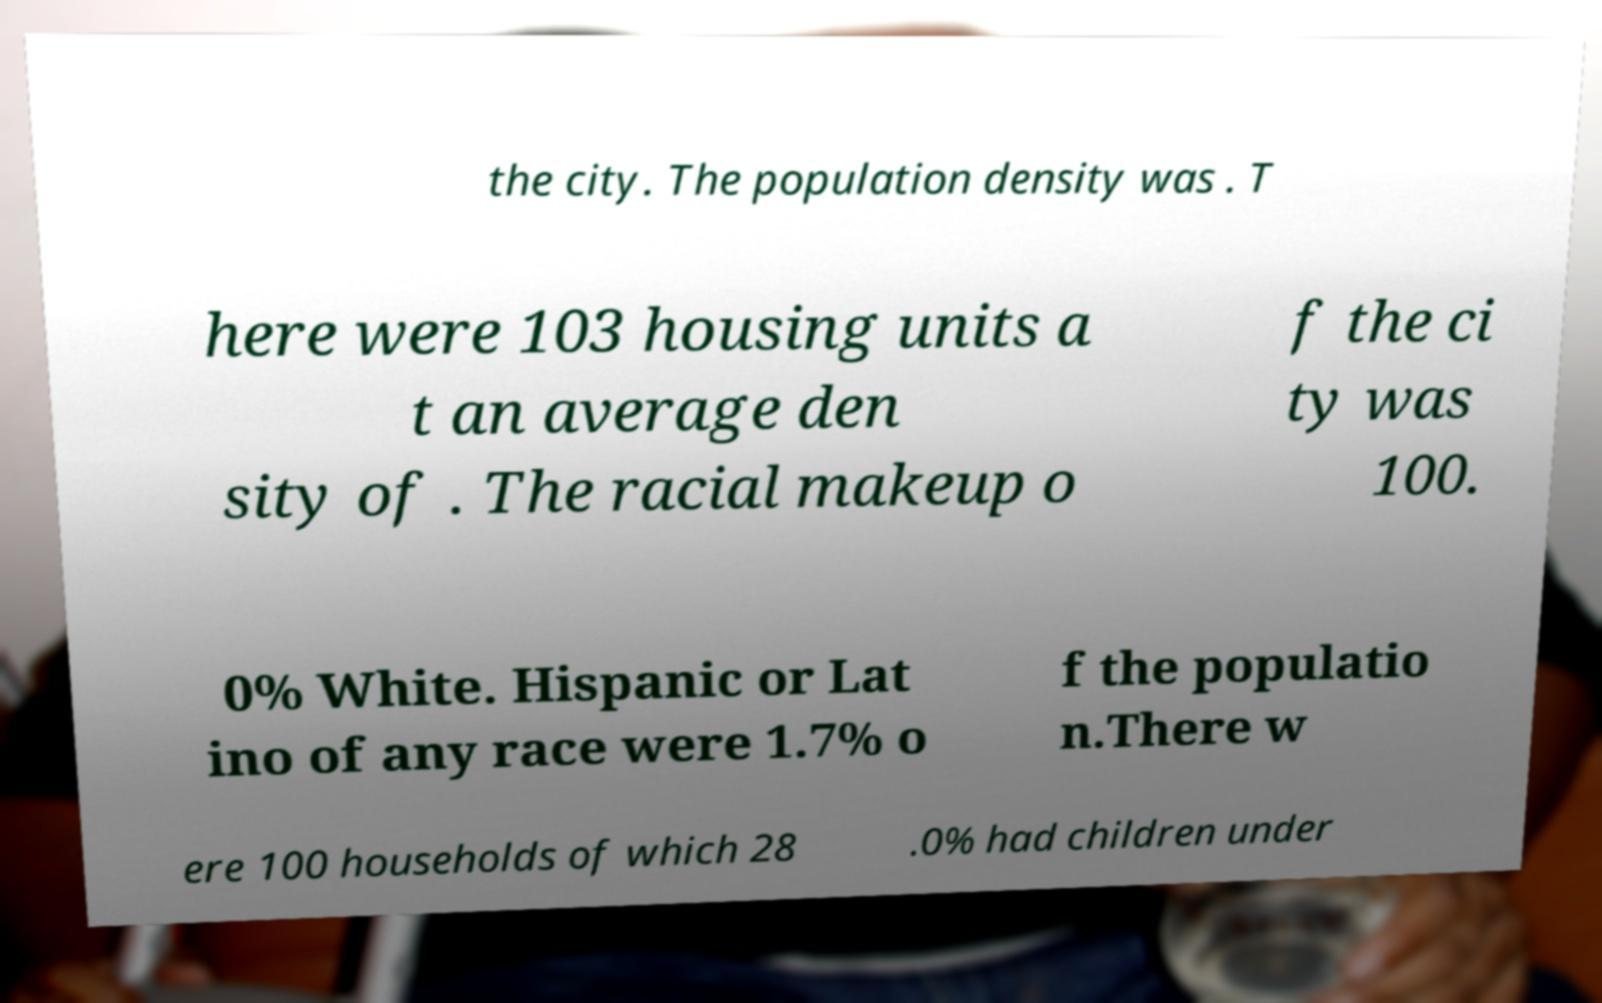Could you extract and type out the text from this image? the city. The population density was . T here were 103 housing units a t an average den sity of . The racial makeup o f the ci ty was 100. 0% White. Hispanic or Lat ino of any race were 1.7% o f the populatio n.There w ere 100 households of which 28 .0% had children under 